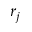Convert formula to latex. <formula><loc_0><loc_0><loc_500><loc_500>r _ { j }</formula> 